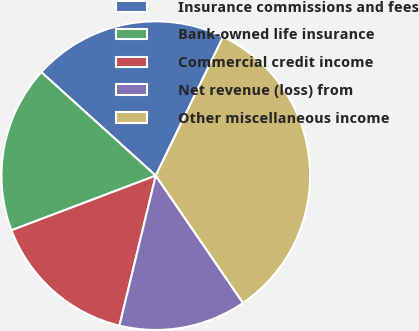Convert chart to OTSL. <chart><loc_0><loc_0><loc_500><loc_500><pie_chart><fcel>Insurance commissions and fees<fcel>Bank-owned life insurance<fcel>Commercial credit income<fcel>Net revenue (loss) from<fcel>Other miscellaneous income<nl><fcel>20.49%<fcel>17.46%<fcel>15.46%<fcel>13.34%<fcel>33.25%<nl></chart> 